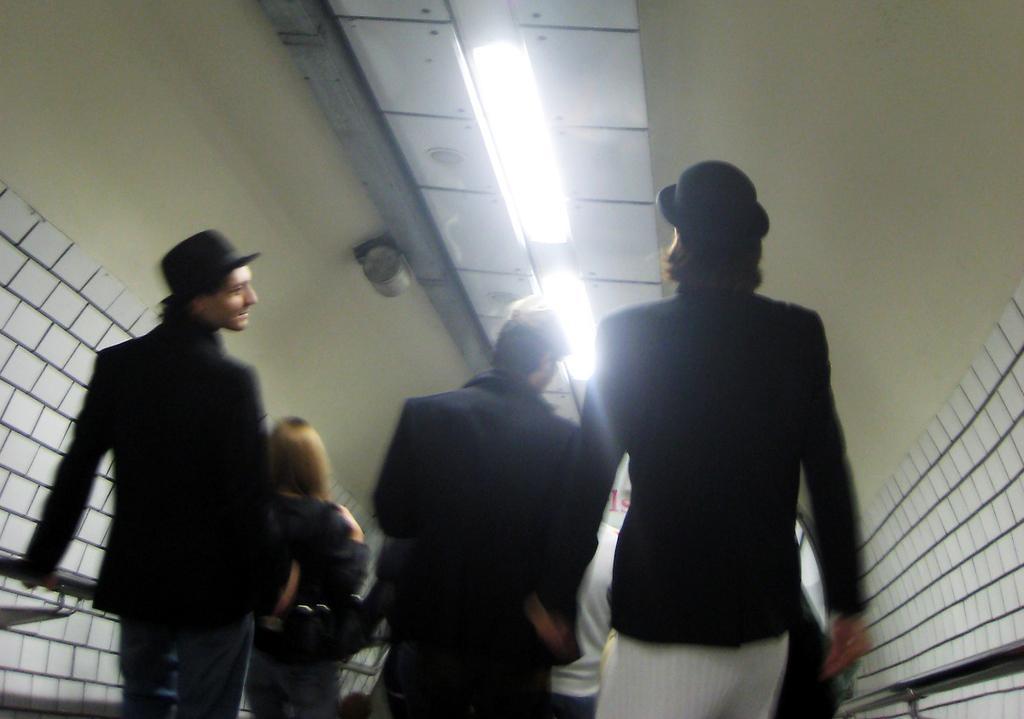Could you give a brief overview of what you see in this image? In the center of the image there are people. At the top of the image there is a ceiling with lights. To the right side of the image there is a wall. There is a railing. 